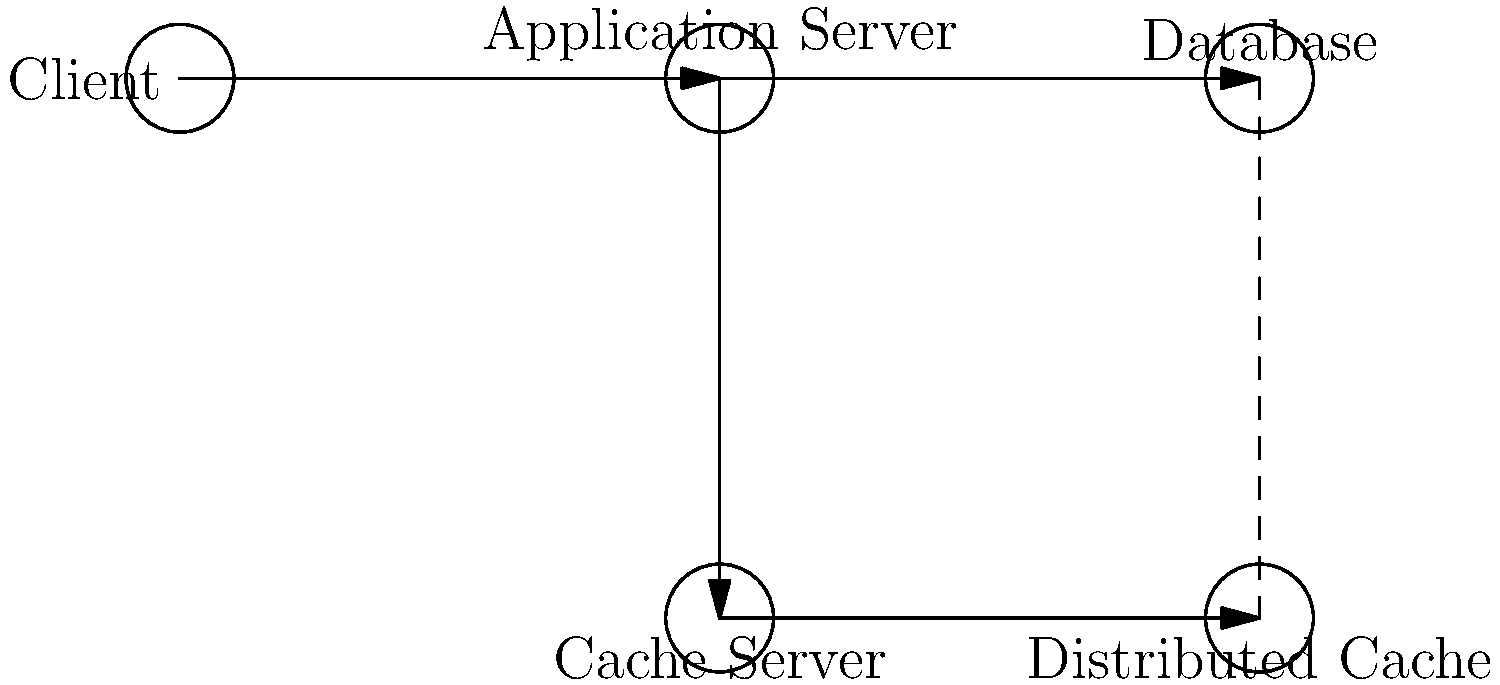In the multi-tier architecture diagram shown above, which caching mechanism would be most effective for reducing database load and improving response times for frequently accessed data that changes infrequently? To answer this question, let's analyze the components and their interactions in the system:

1. The diagram shows a multi-tier architecture with a Client, Application Server, Database, Cache Server, and Distributed Cache.

2. The Application Server is connected to both the Database and the Cache Server.

3. The Cache Server is connected to a Distributed Cache system.

4. There's a dashed line between the Database and the Distributed Cache, indicating a potential relationship.

Now, let's consider the caching mechanisms:

1. Local caching on the Application Server:
   - Pros: Fast access, reduces network calls
   - Cons: Limited storage, not shared across multiple application servers

2. Centralized Cache Server:
   - Pros: Shared cache, reduces database load
   - Cons: Single point of failure, potential bottleneck

3. Distributed Cache:
   - Pros: Scalable, fault-tolerant, shared across multiple application servers
   - Cons: Slightly higher latency than local caching

Given the requirement to reduce database load and improve response times for frequently accessed data that changes infrequently, the Distributed Cache is the most effective solution because:

1. It can store large amounts of data, effectively reducing database load.
2. It's shared across multiple application servers, ensuring consistency.
3. It's scalable and fault-tolerant, making it suitable for high-traffic applications.
4. The slight increase in latency compared to local caching is outweighed by the benefits of data consistency and reduced database load.

The dashed line between the Database and Distributed Cache suggests a potential data synchronization mechanism, which would be useful for keeping the cache updated with infrequent changes to the data.
Answer: Distributed Cache 